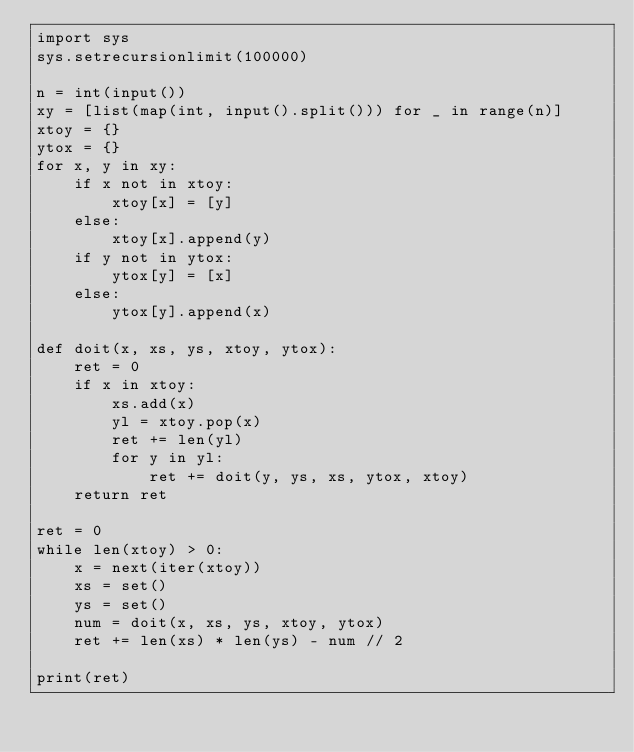<code> <loc_0><loc_0><loc_500><loc_500><_Python_>import sys
sys.setrecursionlimit(100000)

n = int(input())
xy = [list(map(int, input().split())) for _ in range(n)]
xtoy = {}
ytox = {}
for x, y in xy:
    if x not in xtoy:
        xtoy[x] = [y]
    else:
        xtoy[x].append(y)
    if y not in ytox:
        ytox[y] = [x]
    else:
        ytox[y].append(x)

def doit(x, xs, ys, xtoy, ytox):
    ret = 0
    if x in xtoy:
        xs.add(x)
        yl = xtoy.pop(x)
        ret += len(yl)
        for y in yl:
            ret += doit(y, ys, xs, ytox, xtoy)
    return ret

ret = 0
while len(xtoy) > 0:
    x = next(iter(xtoy))
    xs = set()
    ys = set()
    num = doit(x, xs, ys, xtoy, ytox)
    ret += len(xs) * len(ys) - num // 2

print(ret)</code> 